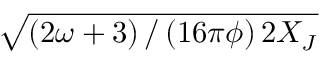<formula> <loc_0><loc_0><loc_500><loc_500>\sqrt { \left ( { 2 \omega + 3 } \right ) / \left ( { 1 6 \pi \phi } \right ) 2 X _ { J } }</formula> 